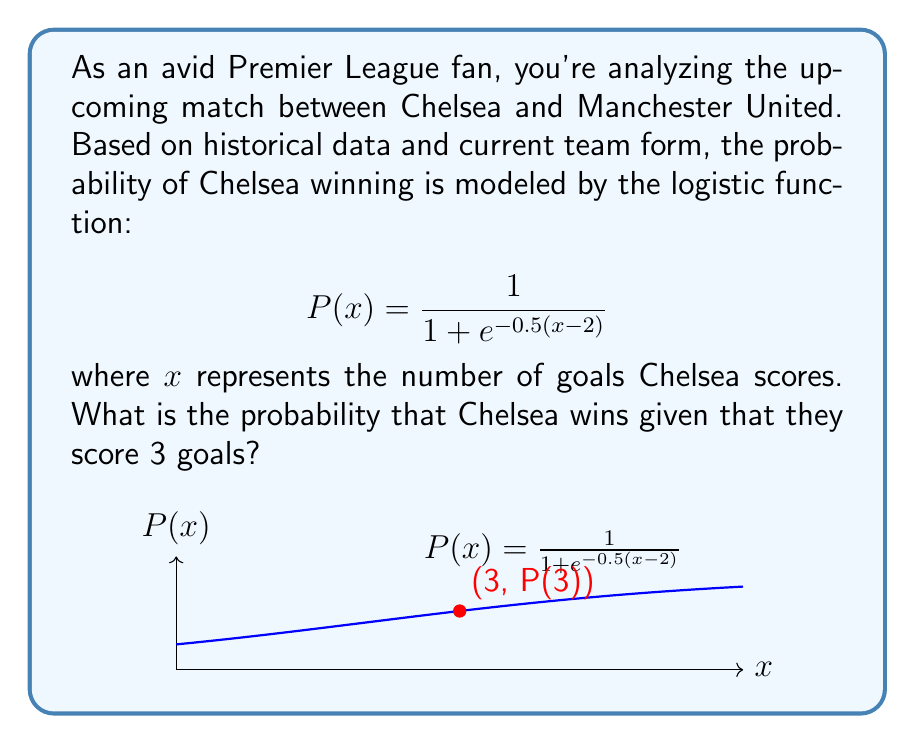Give your solution to this math problem. Let's approach this step-by-step:

1) We're given the logistic function:
   $$P(x) = \frac{1}{1 + e^{-0.5(x-2)}}$$

2) We need to find $P(3)$, which represents the probability of Chelsea winning when they score 3 goals.

3) Let's substitute $x = 3$ into the function:
   $$P(3) = \frac{1}{1 + e^{-0.5(3-2)}}$$

4) Simplify the exponent:
   $$P(3) = \frac{1}{1 + e^{-0.5(1)}} = \frac{1}{1 + e^{-0.5}}$$

5) Calculate $e^{-0.5}$:
   $e^{-0.5} \approx 0.6065$

6) Substitute this value:
   $$P(3) = \frac{1}{1 + 0.6065} = \frac{1}{1.6065}$$

7) Perform the division:
   $$P(3) \approx 0.6225$$

8) Convert to a percentage:
   $0.6225 \times 100\% = 62.25\%$

Therefore, the probability that Chelsea wins given that they score 3 goals is approximately 62.25%.
Answer: 62.25% 